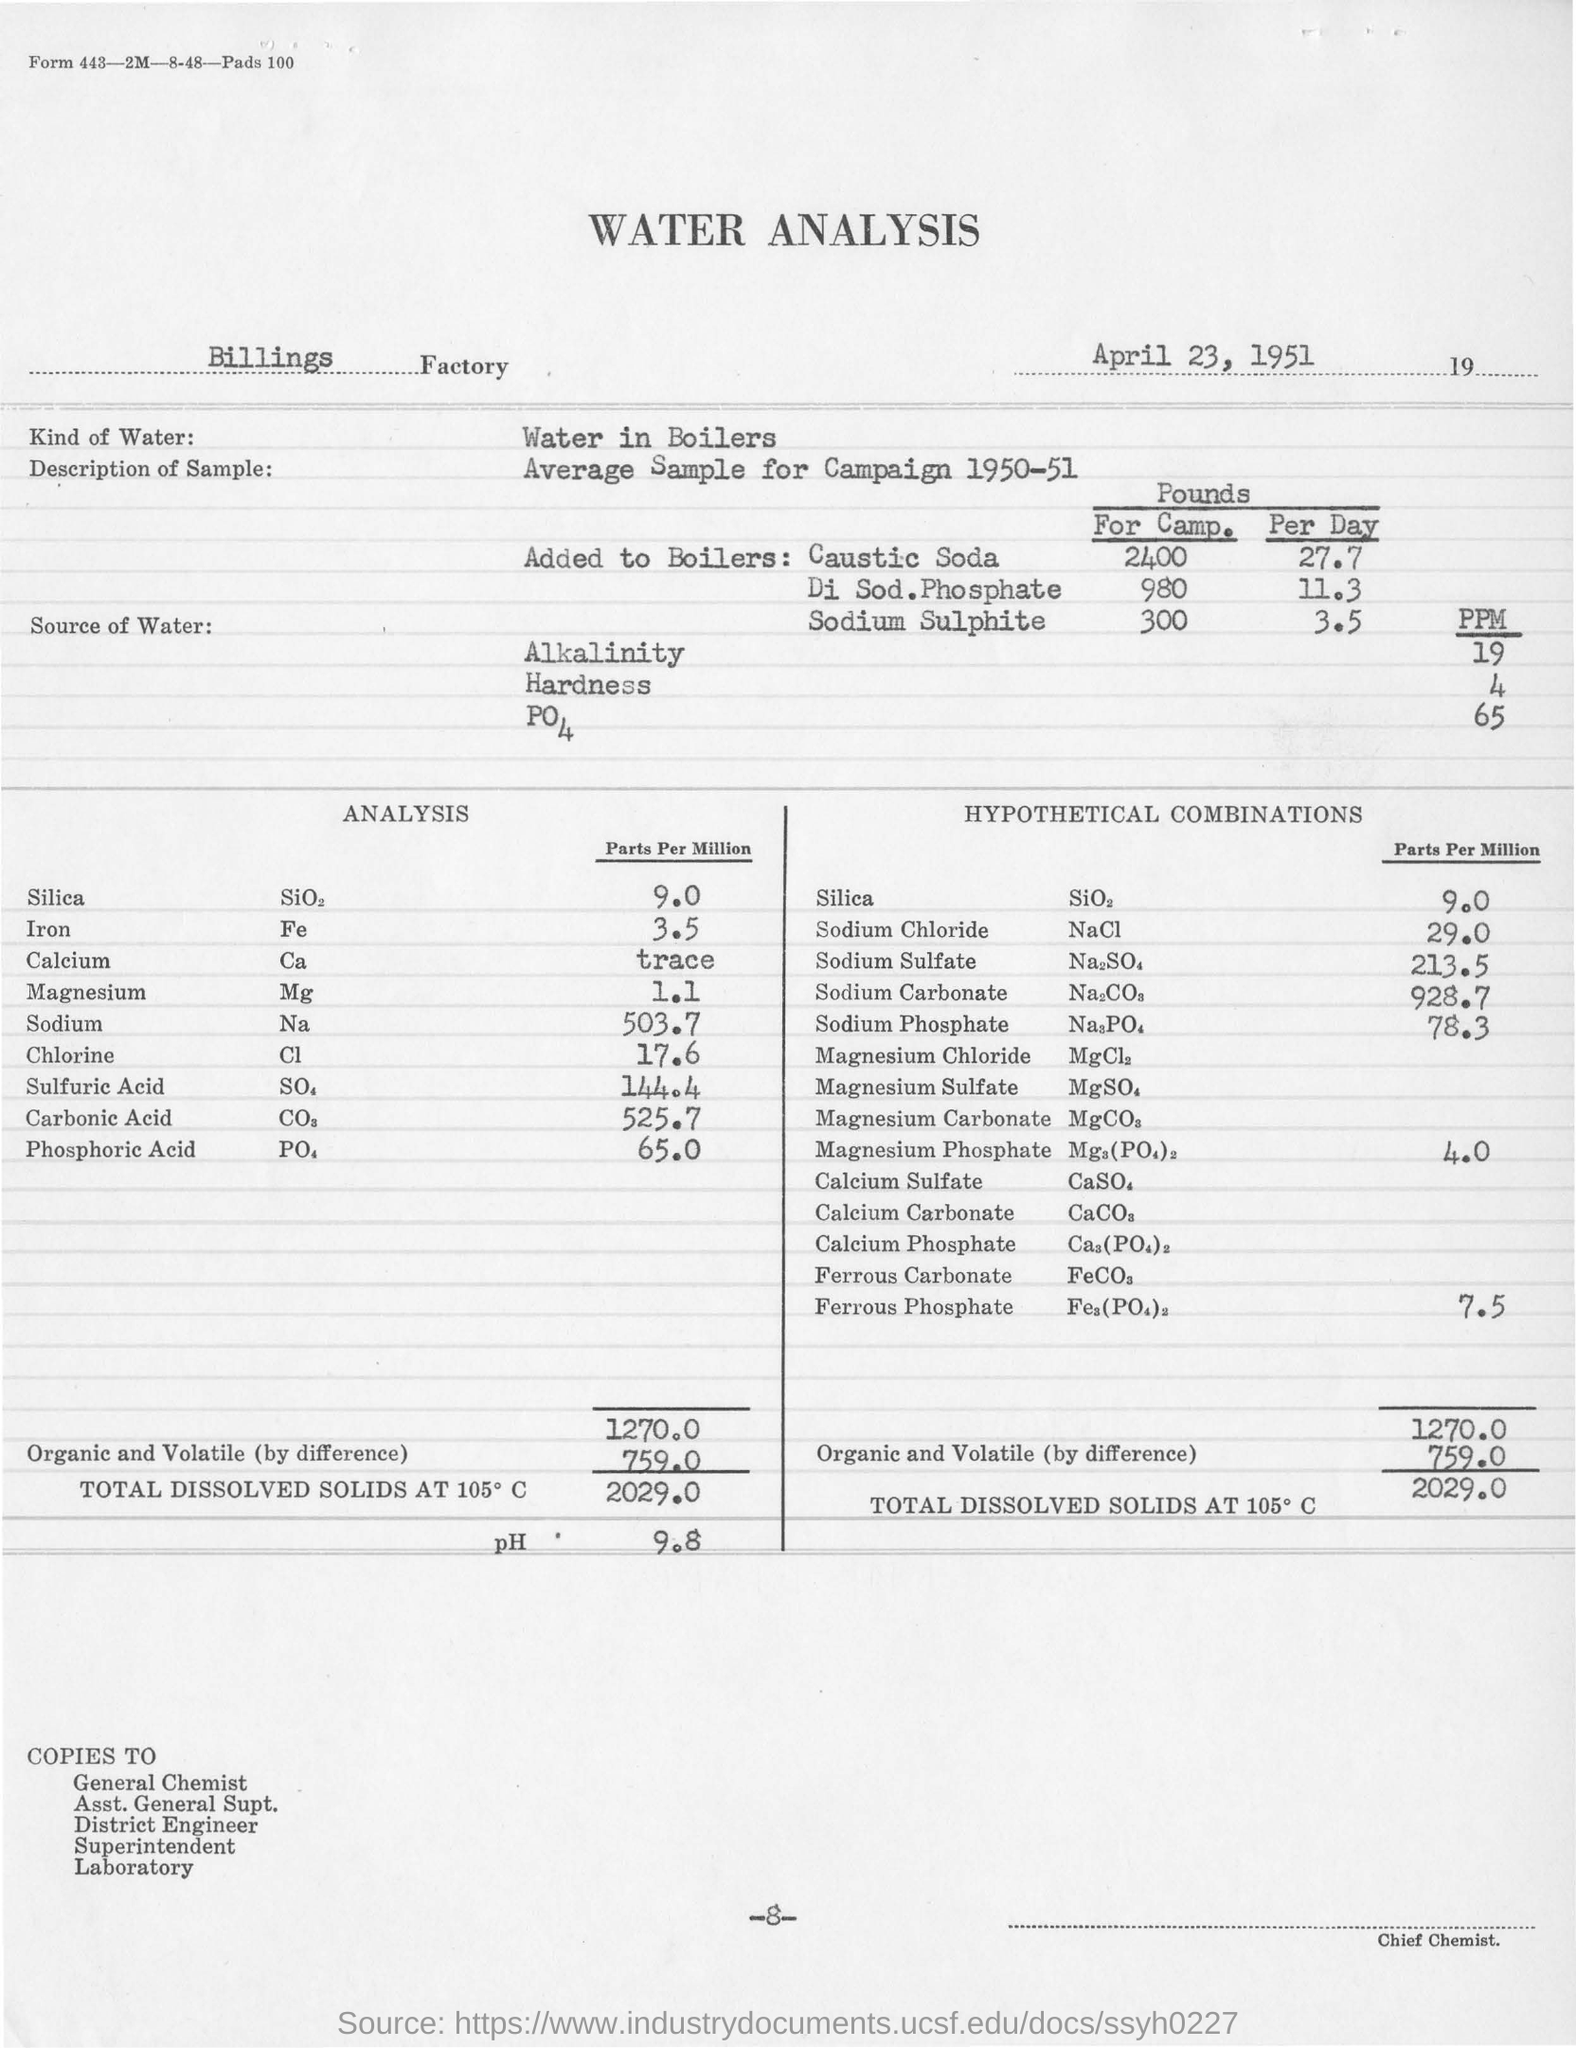Outline some significant characteristics in this image. The type of water used in boilers is known as boiler water. The average sample of water analysis was conducted in the year 1950-51. A quantity of chlorine is used for analysis, specifically 17.6 milliliters. 